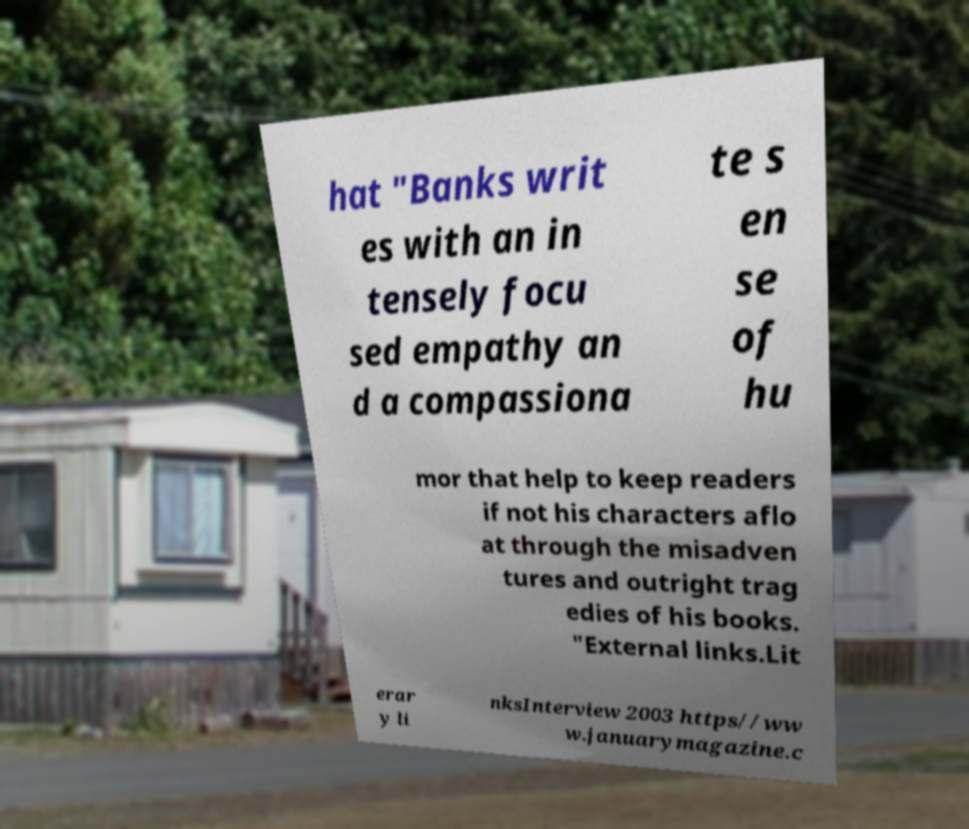Can you accurately transcribe the text from the provided image for me? hat "Banks writ es with an in tensely focu sed empathy an d a compassiona te s en se of hu mor that help to keep readers if not his characters aflo at through the misadven tures and outright trag edies of his books. "External links.Lit erar y li nksInterview 2003 https//ww w.januarymagazine.c 